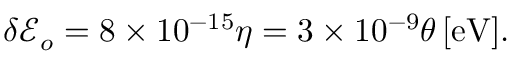Convert formula to latex. <formula><loc_0><loc_0><loc_500><loc_500>\begin{array} { r } { \delta { { \mathcal { E } } } _ { o } = 8 \times 1 0 ^ { - 1 5 } \eta = 3 \times 1 0 ^ { - 9 } \theta { \, [ e V ] } . } \end{array}</formula> 